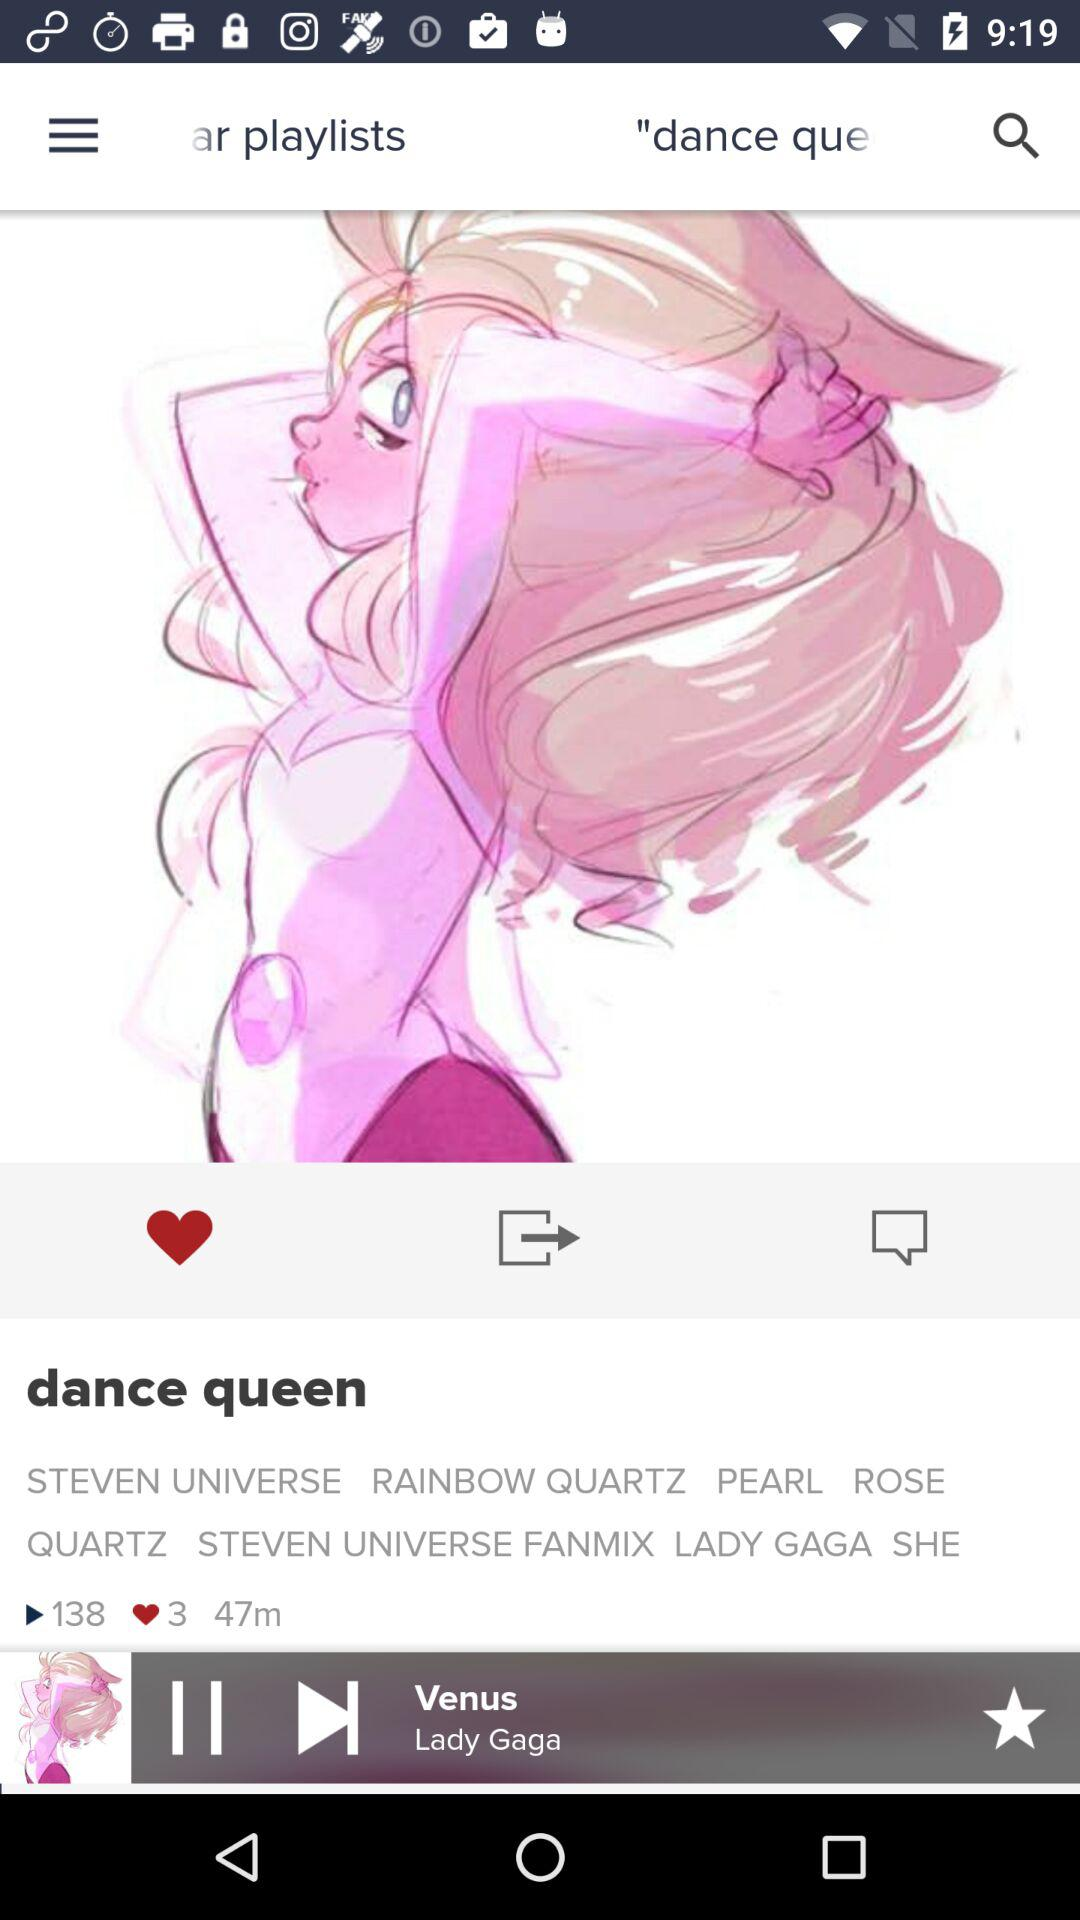How many likes does the playlist "dance queen" get? There are 3 likes. 